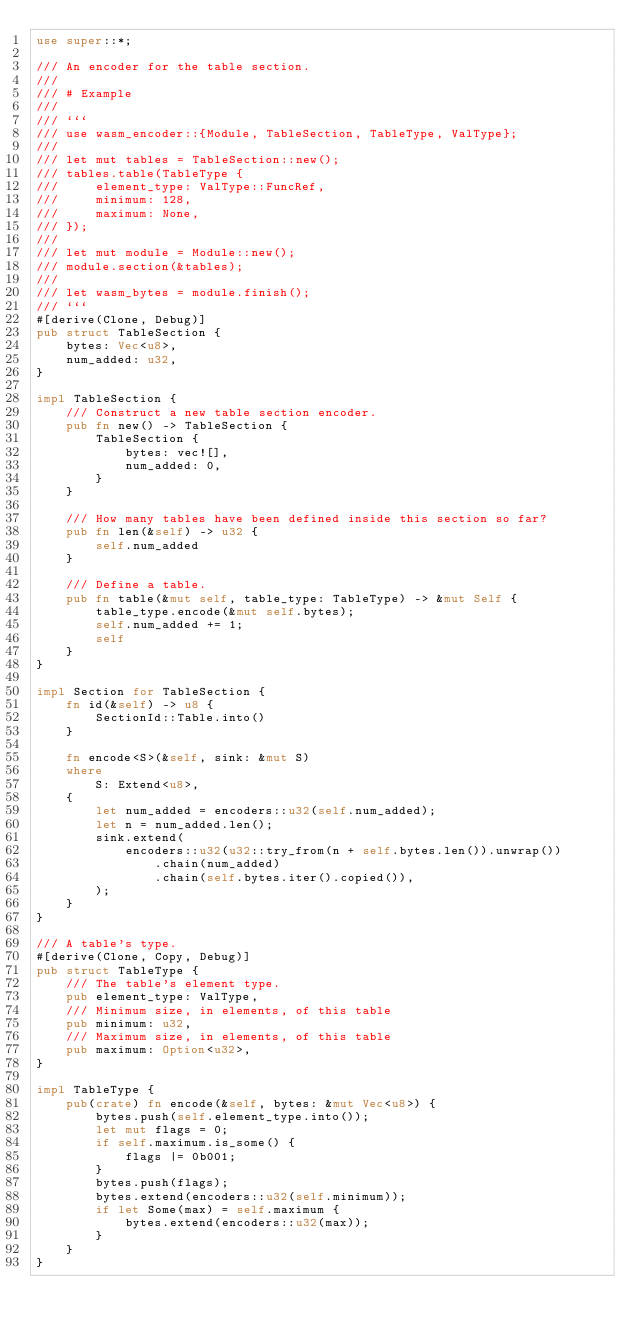<code> <loc_0><loc_0><loc_500><loc_500><_Rust_>use super::*;

/// An encoder for the table section.
///
/// # Example
///
/// ```
/// use wasm_encoder::{Module, TableSection, TableType, ValType};
///
/// let mut tables = TableSection::new();
/// tables.table(TableType {
///     element_type: ValType::FuncRef,
///     minimum: 128,
///     maximum: None,
/// });
///
/// let mut module = Module::new();
/// module.section(&tables);
///
/// let wasm_bytes = module.finish();
/// ```
#[derive(Clone, Debug)]
pub struct TableSection {
    bytes: Vec<u8>,
    num_added: u32,
}

impl TableSection {
    /// Construct a new table section encoder.
    pub fn new() -> TableSection {
        TableSection {
            bytes: vec![],
            num_added: 0,
        }
    }

    /// How many tables have been defined inside this section so far?
    pub fn len(&self) -> u32 {
        self.num_added
    }

    /// Define a table.
    pub fn table(&mut self, table_type: TableType) -> &mut Self {
        table_type.encode(&mut self.bytes);
        self.num_added += 1;
        self
    }
}

impl Section for TableSection {
    fn id(&self) -> u8 {
        SectionId::Table.into()
    }

    fn encode<S>(&self, sink: &mut S)
    where
        S: Extend<u8>,
    {
        let num_added = encoders::u32(self.num_added);
        let n = num_added.len();
        sink.extend(
            encoders::u32(u32::try_from(n + self.bytes.len()).unwrap())
                .chain(num_added)
                .chain(self.bytes.iter().copied()),
        );
    }
}

/// A table's type.
#[derive(Clone, Copy, Debug)]
pub struct TableType {
    /// The table's element type.
    pub element_type: ValType,
    /// Minimum size, in elements, of this table
    pub minimum: u32,
    /// Maximum size, in elements, of this table
    pub maximum: Option<u32>,
}

impl TableType {
    pub(crate) fn encode(&self, bytes: &mut Vec<u8>) {
        bytes.push(self.element_type.into());
        let mut flags = 0;
        if self.maximum.is_some() {
            flags |= 0b001;
        }
        bytes.push(flags);
        bytes.extend(encoders::u32(self.minimum));
        if let Some(max) = self.maximum {
            bytes.extend(encoders::u32(max));
        }
    }
}
</code> 